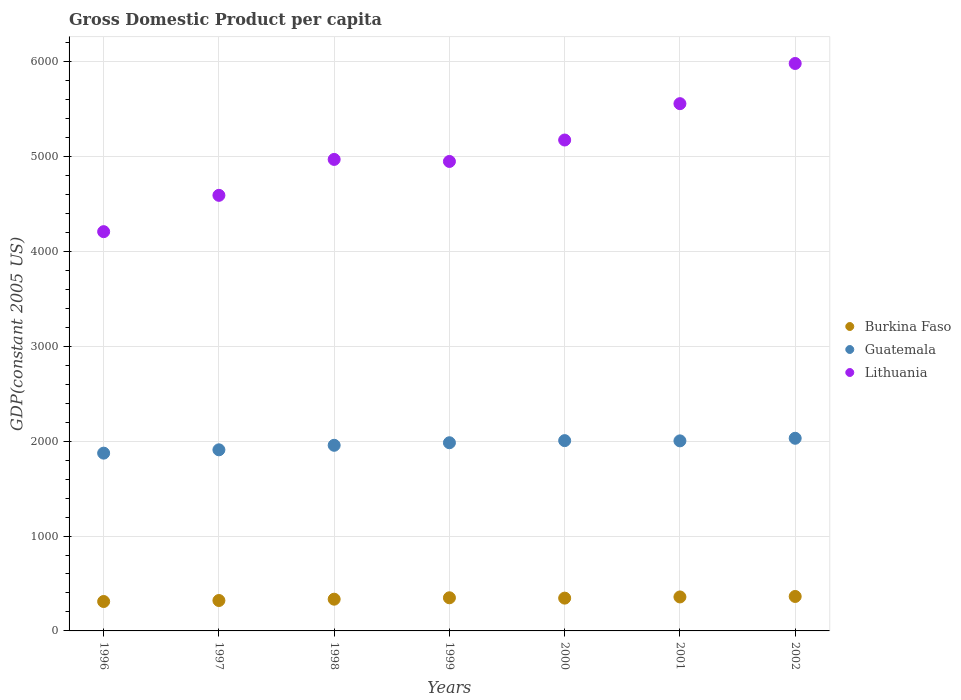How many different coloured dotlines are there?
Offer a very short reply. 3. Is the number of dotlines equal to the number of legend labels?
Offer a terse response. Yes. What is the GDP per capita in Lithuania in 1996?
Provide a succinct answer. 4207.88. Across all years, what is the maximum GDP per capita in Burkina Faso?
Keep it short and to the point. 363.15. Across all years, what is the minimum GDP per capita in Burkina Faso?
Make the answer very short. 310.01. In which year was the GDP per capita in Lithuania maximum?
Give a very brief answer. 2002. In which year was the GDP per capita in Lithuania minimum?
Provide a succinct answer. 1996. What is the total GDP per capita in Guatemala in the graph?
Offer a very short reply. 1.38e+04. What is the difference between the GDP per capita in Burkina Faso in 1997 and that in 2001?
Ensure brevity in your answer.  -37.58. What is the difference between the GDP per capita in Lithuania in 2002 and the GDP per capita in Burkina Faso in 1997?
Your answer should be compact. 5659.81. What is the average GDP per capita in Burkina Faso per year?
Offer a terse response. 340.16. In the year 2001, what is the difference between the GDP per capita in Guatemala and GDP per capita in Burkina Faso?
Offer a very short reply. 1644.84. What is the ratio of the GDP per capita in Guatemala in 1999 to that in 2001?
Offer a very short reply. 0.99. Is the difference between the GDP per capita in Guatemala in 1996 and 1998 greater than the difference between the GDP per capita in Burkina Faso in 1996 and 1998?
Give a very brief answer. No. What is the difference between the highest and the second highest GDP per capita in Burkina Faso?
Ensure brevity in your answer.  5.03. What is the difference between the highest and the lowest GDP per capita in Burkina Faso?
Provide a succinct answer. 53.14. Is the sum of the GDP per capita in Guatemala in 1996 and 2000 greater than the maximum GDP per capita in Lithuania across all years?
Provide a short and direct response. No. Is it the case that in every year, the sum of the GDP per capita in Burkina Faso and GDP per capita in Guatemala  is greater than the GDP per capita in Lithuania?
Your response must be concise. No. Does the GDP per capita in Burkina Faso monotonically increase over the years?
Ensure brevity in your answer.  No. What is the difference between two consecutive major ticks on the Y-axis?
Ensure brevity in your answer.  1000. Are the values on the major ticks of Y-axis written in scientific E-notation?
Your answer should be very brief. No. How are the legend labels stacked?
Make the answer very short. Vertical. What is the title of the graph?
Your response must be concise. Gross Domestic Product per capita. What is the label or title of the Y-axis?
Your response must be concise. GDP(constant 2005 US). What is the GDP(constant 2005 US) in Burkina Faso in 1996?
Make the answer very short. 310.01. What is the GDP(constant 2005 US) of Guatemala in 1996?
Your answer should be very brief. 1873.62. What is the GDP(constant 2005 US) of Lithuania in 1996?
Your answer should be very brief. 4207.88. What is the GDP(constant 2005 US) in Burkina Faso in 1997?
Make the answer very short. 320.54. What is the GDP(constant 2005 US) in Guatemala in 1997?
Keep it short and to the point. 1908.72. What is the GDP(constant 2005 US) in Lithuania in 1997?
Offer a terse response. 4590.59. What is the GDP(constant 2005 US) of Burkina Faso in 1998?
Make the answer very short. 334.45. What is the GDP(constant 2005 US) in Guatemala in 1998?
Offer a terse response. 1956.34. What is the GDP(constant 2005 US) of Lithuania in 1998?
Make the answer very short. 4969.25. What is the GDP(constant 2005 US) in Burkina Faso in 1999?
Provide a short and direct response. 349.22. What is the GDP(constant 2005 US) in Guatemala in 1999?
Offer a very short reply. 1983.16. What is the GDP(constant 2005 US) in Lithuania in 1999?
Your response must be concise. 4947.85. What is the GDP(constant 2005 US) of Burkina Faso in 2000?
Provide a succinct answer. 345.62. What is the GDP(constant 2005 US) in Guatemala in 2000?
Keep it short and to the point. 2005.54. What is the GDP(constant 2005 US) in Lithuania in 2000?
Your answer should be very brief. 5173.69. What is the GDP(constant 2005 US) of Burkina Faso in 2001?
Give a very brief answer. 358.12. What is the GDP(constant 2005 US) in Guatemala in 2001?
Keep it short and to the point. 2002.96. What is the GDP(constant 2005 US) of Lithuania in 2001?
Provide a short and direct response. 5556.85. What is the GDP(constant 2005 US) of Burkina Faso in 2002?
Keep it short and to the point. 363.15. What is the GDP(constant 2005 US) in Guatemala in 2002?
Your response must be concise. 2030.31. What is the GDP(constant 2005 US) in Lithuania in 2002?
Provide a succinct answer. 5980.35. Across all years, what is the maximum GDP(constant 2005 US) in Burkina Faso?
Your answer should be very brief. 363.15. Across all years, what is the maximum GDP(constant 2005 US) of Guatemala?
Offer a terse response. 2030.31. Across all years, what is the maximum GDP(constant 2005 US) in Lithuania?
Provide a short and direct response. 5980.35. Across all years, what is the minimum GDP(constant 2005 US) in Burkina Faso?
Provide a short and direct response. 310.01. Across all years, what is the minimum GDP(constant 2005 US) of Guatemala?
Your answer should be very brief. 1873.62. Across all years, what is the minimum GDP(constant 2005 US) in Lithuania?
Keep it short and to the point. 4207.88. What is the total GDP(constant 2005 US) of Burkina Faso in the graph?
Ensure brevity in your answer.  2381.12. What is the total GDP(constant 2005 US) in Guatemala in the graph?
Keep it short and to the point. 1.38e+04. What is the total GDP(constant 2005 US) of Lithuania in the graph?
Give a very brief answer. 3.54e+04. What is the difference between the GDP(constant 2005 US) in Burkina Faso in 1996 and that in 1997?
Keep it short and to the point. -10.53. What is the difference between the GDP(constant 2005 US) of Guatemala in 1996 and that in 1997?
Keep it short and to the point. -35.1. What is the difference between the GDP(constant 2005 US) in Lithuania in 1996 and that in 1997?
Keep it short and to the point. -382.71. What is the difference between the GDP(constant 2005 US) of Burkina Faso in 1996 and that in 1998?
Give a very brief answer. -24.44. What is the difference between the GDP(constant 2005 US) of Guatemala in 1996 and that in 1998?
Ensure brevity in your answer.  -82.72. What is the difference between the GDP(constant 2005 US) of Lithuania in 1996 and that in 1998?
Your response must be concise. -761.37. What is the difference between the GDP(constant 2005 US) of Burkina Faso in 1996 and that in 1999?
Your answer should be compact. -39.21. What is the difference between the GDP(constant 2005 US) in Guatemala in 1996 and that in 1999?
Give a very brief answer. -109.54. What is the difference between the GDP(constant 2005 US) of Lithuania in 1996 and that in 1999?
Ensure brevity in your answer.  -739.97. What is the difference between the GDP(constant 2005 US) of Burkina Faso in 1996 and that in 2000?
Your answer should be very brief. -35.61. What is the difference between the GDP(constant 2005 US) in Guatemala in 1996 and that in 2000?
Give a very brief answer. -131.92. What is the difference between the GDP(constant 2005 US) of Lithuania in 1996 and that in 2000?
Provide a succinct answer. -965.82. What is the difference between the GDP(constant 2005 US) in Burkina Faso in 1996 and that in 2001?
Offer a very short reply. -48.11. What is the difference between the GDP(constant 2005 US) of Guatemala in 1996 and that in 2001?
Your answer should be very brief. -129.34. What is the difference between the GDP(constant 2005 US) in Lithuania in 1996 and that in 2001?
Offer a very short reply. -1348.97. What is the difference between the GDP(constant 2005 US) in Burkina Faso in 1996 and that in 2002?
Give a very brief answer. -53.14. What is the difference between the GDP(constant 2005 US) of Guatemala in 1996 and that in 2002?
Provide a succinct answer. -156.69. What is the difference between the GDP(constant 2005 US) of Lithuania in 1996 and that in 2002?
Your answer should be very brief. -1772.47. What is the difference between the GDP(constant 2005 US) in Burkina Faso in 1997 and that in 1998?
Keep it short and to the point. -13.91. What is the difference between the GDP(constant 2005 US) in Guatemala in 1997 and that in 1998?
Ensure brevity in your answer.  -47.62. What is the difference between the GDP(constant 2005 US) of Lithuania in 1997 and that in 1998?
Provide a succinct answer. -378.66. What is the difference between the GDP(constant 2005 US) in Burkina Faso in 1997 and that in 1999?
Provide a short and direct response. -28.68. What is the difference between the GDP(constant 2005 US) of Guatemala in 1997 and that in 1999?
Ensure brevity in your answer.  -74.45. What is the difference between the GDP(constant 2005 US) in Lithuania in 1997 and that in 1999?
Make the answer very short. -357.25. What is the difference between the GDP(constant 2005 US) in Burkina Faso in 1997 and that in 2000?
Offer a very short reply. -25.09. What is the difference between the GDP(constant 2005 US) in Guatemala in 1997 and that in 2000?
Make the answer very short. -96.82. What is the difference between the GDP(constant 2005 US) in Lithuania in 1997 and that in 2000?
Provide a succinct answer. -583.1. What is the difference between the GDP(constant 2005 US) in Burkina Faso in 1997 and that in 2001?
Your answer should be compact. -37.58. What is the difference between the GDP(constant 2005 US) in Guatemala in 1997 and that in 2001?
Offer a very short reply. -94.24. What is the difference between the GDP(constant 2005 US) of Lithuania in 1997 and that in 2001?
Your answer should be compact. -966.26. What is the difference between the GDP(constant 2005 US) of Burkina Faso in 1997 and that in 2002?
Your answer should be very brief. -42.61. What is the difference between the GDP(constant 2005 US) in Guatemala in 1997 and that in 2002?
Keep it short and to the point. -121.6. What is the difference between the GDP(constant 2005 US) in Lithuania in 1997 and that in 2002?
Give a very brief answer. -1389.76. What is the difference between the GDP(constant 2005 US) of Burkina Faso in 1998 and that in 1999?
Give a very brief answer. -14.77. What is the difference between the GDP(constant 2005 US) in Guatemala in 1998 and that in 1999?
Provide a short and direct response. -26.83. What is the difference between the GDP(constant 2005 US) of Lithuania in 1998 and that in 1999?
Provide a succinct answer. 21.4. What is the difference between the GDP(constant 2005 US) of Burkina Faso in 1998 and that in 2000?
Provide a short and direct response. -11.17. What is the difference between the GDP(constant 2005 US) of Guatemala in 1998 and that in 2000?
Offer a terse response. -49.2. What is the difference between the GDP(constant 2005 US) of Lithuania in 1998 and that in 2000?
Your answer should be compact. -204.45. What is the difference between the GDP(constant 2005 US) in Burkina Faso in 1998 and that in 2001?
Offer a very short reply. -23.67. What is the difference between the GDP(constant 2005 US) of Guatemala in 1998 and that in 2001?
Your answer should be very brief. -46.62. What is the difference between the GDP(constant 2005 US) in Lithuania in 1998 and that in 2001?
Your response must be concise. -587.6. What is the difference between the GDP(constant 2005 US) in Burkina Faso in 1998 and that in 2002?
Offer a very short reply. -28.7. What is the difference between the GDP(constant 2005 US) of Guatemala in 1998 and that in 2002?
Provide a succinct answer. -73.98. What is the difference between the GDP(constant 2005 US) in Lithuania in 1998 and that in 2002?
Keep it short and to the point. -1011.1. What is the difference between the GDP(constant 2005 US) in Burkina Faso in 1999 and that in 2000?
Give a very brief answer. 3.6. What is the difference between the GDP(constant 2005 US) of Guatemala in 1999 and that in 2000?
Provide a short and direct response. -22.38. What is the difference between the GDP(constant 2005 US) in Lithuania in 1999 and that in 2000?
Ensure brevity in your answer.  -225.85. What is the difference between the GDP(constant 2005 US) in Burkina Faso in 1999 and that in 2001?
Provide a short and direct response. -8.9. What is the difference between the GDP(constant 2005 US) of Guatemala in 1999 and that in 2001?
Make the answer very short. -19.79. What is the difference between the GDP(constant 2005 US) of Lithuania in 1999 and that in 2001?
Make the answer very short. -609. What is the difference between the GDP(constant 2005 US) of Burkina Faso in 1999 and that in 2002?
Provide a short and direct response. -13.93. What is the difference between the GDP(constant 2005 US) in Guatemala in 1999 and that in 2002?
Provide a short and direct response. -47.15. What is the difference between the GDP(constant 2005 US) of Lithuania in 1999 and that in 2002?
Offer a terse response. -1032.5. What is the difference between the GDP(constant 2005 US) in Burkina Faso in 2000 and that in 2001?
Make the answer very short. -12.5. What is the difference between the GDP(constant 2005 US) in Guatemala in 2000 and that in 2001?
Offer a very short reply. 2.58. What is the difference between the GDP(constant 2005 US) in Lithuania in 2000 and that in 2001?
Your answer should be compact. -383.15. What is the difference between the GDP(constant 2005 US) of Burkina Faso in 2000 and that in 2002?
Offer a very short reply. -17.53. What is the difference between the GDP(constant 2005 US) of Guatemala in 2000 and that in 2002?
Ensure brevity in your answer.  -24.77. What is the difference between the GDP(constant 2005 US) in Lithuania in 2000 and that in 2002?
Offer a very short reply. -806.66. What is the difference between the GDP(constant 2005 US) in Burkina Faso in 2001 and that in 2002?
Ensure brevity in your answer.  -5.03. What is the difference between the GDP(constant 2005 US) of Guatemala in 2001 and that in 2002?
Give a very brief answer. -27.36. What is the difference between the GDP(constant 2005 US) in Lithuania in 2001 and that in 2002?
Your answer should be very brief. -423.5. What is the difference between the GDP(constant 2005 US) in Burkina Faso in 1996 and the GDP(constant 2005 US) in Guatemala in 1997?
Offer a very short reply. -1598.71. What is the difference between the GDP(constant 2005 US) of Burkina Faso in 1996 and the GDP(constant 2005 US) of Lithuania in 1997?
Make the answer very short. -4280.58. What is the difference between the GDP(constant 2005 US) in Guatemala in 1996 and the GDP(constant 2005 US) in Lithuania in 1997?
Provide a short and direct response. -2716.97. What is the difference between the GDP(constant 2005 US) of Burkina Faso in 1996 and the GDP(constant 2005 US) of Guatemala in 1998?
Keep it short and to the point. -1646.33. What is the difference between the GDP(constant 2005 US) of Burkina Faso in 1996 and the GDP(constant 2005 US) of Lithuania in 1998?
Provide a succinct answer. -4659.24. What is the difference between the GDP(constant 2005 US) of Guatemala in 1996 and the GDP(constant 2005 US) of Lithuania in 1998?
Offer a terse response. -3095.63. What is the difference between the GDP(constant 2005 US) of Burkina Faso in 1996 and the GDP(constant 2005 US) of Guatemala in 1999?
Your response must be concise. -1673.15. What is the difference between the GDP(constant 2005 US) in Burkina Faso in 1996 and the GDP(constant 2005 US) in Lithuania in 1999?
Your answer should be very brief. -4637.84. What is the difference between the GDP(constant 2005 US) in Guatemala in 1996 and the GDP(constant 2005 US) in Lithuania in 1999?
Give a very brief answer. -3074.23. What is the difference between the GDP(constant 2005 US) in Burkina Faso in 1996 and the GDP(constant 2005 US) in Guatemala in 2000?
Give a very brief answer. -1695.53. What is the difference between the GDP(constant 2005 US) of Burkina Faso in 1996 and the GDP(constant 2005 US) of Lithuania in 2000?
Give a very brief answer. -4863.69. What is the difference between the GDP(constant 2005 US) of Guatemala in 1996 and the GDP(constant 2005 US) of Lithuania in 2000?
Offer a very short reply. -3300.07. What is the difference between the GDP(constant 2005 US) in Burkina Faso in 1996 and the GDP(constant 2005 US) in Guatemala in 2001?
Your answer should be very brief. -1692.95. What is the difference between the GDP(constant 2005 US) in Burkina Faso in 1996 and the GDP(constant 2005 US) in Lithuania in 2001?
Make the answer very short. -5246.84. What is the difference between the GDP(constant 2005 US) of Guatemala in 1996 and the GDP(constant 2005 US) of Lithuania in 2001?
Your response must be concise. -3683.23. What is the difference between the GDP(constant 2005 US) of Burkina Faso in 1996 and the GDP(constant 2005 US) of Guatemala in 2002?
Offer a very short reply. -1720.3. What is the difference between the GDP(constant 2005 US) of Burkina Faso in 1996 and the GDP(constant 2005 US) of Lithuania in 2002?
Give a very brief answer. -5670.34. What is the difference between the GDP(constant 2005 US) of Guatemala in 1996 and the GDP(constant 2005 US) of Lithuania in 2002?
Make the answer very short. -4106.73. What is the difference between the GDP(constant 2005 US) in Burkina Faso in 1997 and the GDP(constant 2005 US) in Guatemala in 1998?
Your answer should be very brief. -1635.8. What is the difference between the GDP(constant 2005 US) of Burkina Faso in 1997 and the GDP(constant 2005 US) of Lithuania in 1998?
Your answer should be compact. -4648.71. What is the difference between the GDP(constant 2005 US) in Guatemala in 1997 and the GDP(constant 2005 US) in Lithuania in 1998?
Your answer should be very brief. -3060.53. What is the difference between the GDP(constant 2005 US) in Burkina Faso in 1997 and the GDP(constant 2005 US) in Guatemala in 1999?
Offer a terse response. -1662.62. What is the difference between the GDP(constant 2005 US) in Burkina Faso in 1997 and the GDP(constant 2005 US) in Lithuania in 1999?
Your response must be concise. -4627.31. What is the difference between the GDP(constant 2005 US) in Guatemala in 1997 and the GDP(constant 2005 US) in Lithuania in 1999?
Give a very brief answer. -3039.13. What is the difference between the GDP(constant 2005 US) in Burkina Faso in 1997 and the GDP(constant 2005 US) in Guatemala in 2000?
Ensure brevity in your answer.  -1685. What is the difference between the GDP(constant 2005 US) of Burkina Faso in 1997 and the GDP(constant 2005 US) of Lithuania in 2000?
Provide a short and direct response. -4853.16. What is the difference between the GDP(constant 2005 US) of Guatemala in 1997 and the GDP(constant 2005 US) of Lithuania in 2000?
Offer a terse response. -3264.98. What is the difference between the GDP(constant 2005 US) in Burkina Faso in 1997 and the GDP(constant 2005 US) in Guatemala in 2001?
Give a very brief answer. -1682.42. What is the difference between the GDP(constant 2005 US) in Burkina Faso in 1997 and the GDP(constant 2005 US) in Lithuania in 2001?
Provide a short and direct response. -5236.31. What is the difference between the GDP(constant 2005 US) in Guatemala in 1997 and the GDP(constant 2005 US) in Lithuania in 2001?
Keep it short and to the point. -3648.13. What is the difference between the GDP(constant 2005 US) in Burkina Faso in 1997 and the GDP(constant 2005 US) in Guatemala in 2002?
Provide a short and direct response. -1709.77. What is the difference between the GDP(constant 2005 US) of Burkina Faso in 1997 and the GDP(constant 2005 US) of Lithuania in 2002?
Your answer should be compact. -5659.81. What is the difference between the GDP(constant 2005 US) of Guatemala in 1997 and the GDP(constant 2005 US) of Lithuania in 2002?
Give a very brief answer. -4071.63. What is the difference between the GDP(constant 2005 US) in Burkina Faso in 1998 and the GDP(constant 2005 US) in Guatemala in 1999?
Offer a terse response. -1648.71. What is the difference between the GDP(constant 2005 US) in Burkina Faso in 1998 and the GDP(constant 2005 US) in Lithuania in 1999?
Make the answer very short. -4613.39. What is the difference between the GDP(constant 2005 US) of Guatemala in 1998 and the GDP(constant 2005 US) of Lithuania in 1999?
Provide a short and direct response. -2991.51. What is the difference between the GDP(constant 2005 US) in Burkina Faso in 1998 and the GDP(constant 2005 US) in Guatemala in 2000?
Provide a short and direct response. -1671.09. What is the difference between the GDP(constant 2005 US) of Burkina Faso in 1998 and the GDP(constant 2005 US) of Lithuania in 2000?
Give a very brief answer. -4839.24. What is the difference between the GDP(constant 2005 US) of Guatemala in 1998 and the GDP(constant 2005 US) of Lithuania in 2000?
Offer a terse response. -3217.36. What is the difference between the GDP(constant 2005 US) in Burkina Faso in 1998 and the GDP(constant 2005 US) in Guatemala in 2001?
Provide a short and direct response. -1668.51. What is the difference between the GDP(constant 2005 US) in Burkina Faso in 1998 and the GDP(constant 2005 US) in Lithuania in 2001?
Offer a terse response. -5222.4. What is the difference between the GDP(constant 2005 US) of Guatemala in 1998 and the GDP(constant 2005 US) of Lithuania in 2001?
Make the answer very short. -3600.51. What is the difference between the GDP(constant 2005 US) in Burkina Faso in 1998 and the GDP(constant 2005 US) in Guatemala in 2002?
Provide a succinct answer. -1695.86. What is the difference between the GDP(constant 2005 US) in Burkina Faso in 1998 and the GDP(constant 2005 US) in Lithuania in 2002?
Provide a short and direct response. -5645.9. What is the difference between the GDP(constant 2005 US) in Guatemala in 1998 and the GDP(constant 2005 US) in Lithuania in 2002?
Keep it short and to the point. -4024.01. What is the difference between the GDP(constant 2005 US) of Burkina Faso in 1999 and the GDP(constant 2005 US) of Guatemala in 2000?
Provide a short and direct response. -1656.32. What is the difference between the GDP(constant 2005 US) in Burkina Faso in 1999 and the GDP(constant 2005 US) in Lithuania in 2000?
Offer a very short reply. -4824.47. What is the difference between the GDP(constant 2005 US) of Guatemala in 1999 and the GDP(constant 2005 US) of Lithuania in 2000?
Keep it short and to the point. -3190.53. What is the difference between the GDP(constant 2005 US) in Burkina Faso in 1999 and the GDP(constant 2005 US) in Guatemala in 2001?
Your answer should be very brief. -1653.74. What is the difference between the GDP(constant 2005 US) of Burkina Faso in 1999 and the GDP(constant 2005 US) of Lithuania in 2001?
Your response must be concise. -5207.63. What is the difference between the GDP(constant 2005 US) of Guatemala in 1999 and the GDP(constant 2005 US) of Lithuania in 2001?
Your answer should be compact. -3573.69. What is the difference between the GDP(constant 2005 US) in Burkina Faso in 1999 and the GDP(constant 2005 US) in Guatemala in 2002?
Your answer should be very brief. -1681.09. What is the difference between the GDP(constant 2005 US) in Burkina Faso in 1999 and the GDP(constant 2005 US) in Lithuania in 2002?
Offer a terse response. -5631.13. What is the difference between the GDP(constant 2005 US) of Guatemala in 1999 and the GDP(constant 2005 US) of Lithuania in 2002?
Keep it short and to the point. -3997.19. What is the difference between the GDP(constant 2005 US) of Burkina Faso in 2000 and the GDP(constant 2005 US) of Guatemala in 2001?
Provide a succinct answer. -1657.33. What is the difference between the GDP(constant 2005 US) of Burkina Faso in 2000 and the GDP(constant 2005 US) of Lithuania in 2001?
Offer a very short reply. -5211.23. What is the difference between the GDP(constant 2005 US) in Guatemala in 2000 and the GDP(constant 2005 US) in Lithuania in 2001?
Keep it short and to the point. -3551.31. What is the difference between the GDP(constant 2005 US) of Burkina Faso in 2000 and the GDP(constant 2005 US) of Guatemala in 2002?
Your answer should be very brief. -1684.69. What is the difference between the GDP(constant 2005 US) in Burkina Faso in 2000 and the GDP(constant 2005 US) in Lithuania in 2002?
Your answer should be compact. -5634.73. What is the difference between the GDP(constant 2005 US) of Guatemala in 2000 and the GDP(constant 2005 US) of Lithuania in 2002?
Keep it short and to the point. -3974.81. What is the difference between the GDP(constant 2005 US) of Burkina Faso in 2001 and the GDP(constant 2005 US) of Guatemala in 2002?
Provide a succinct answer. -1672.19. What is the difference between the GDP(constant 2005 US) of Burkina Faso in 2001 and the GDP(constant 2005 US) of Lithuania in 2002?
Provide a short and direct response. -5622.23. What is the difference between the GDP(constant 2005 US) of Guatemala in 2001 and the GDP(constant 2005 US) of Lithuania in 2002?
Offer a terse response. -3977.39. What is the average GDP(constant 2005 US) of Burkina Faso per year?
Offer a very short reply. 340.16. What is the average GDP(constant 2005 US) in Guatemala per year?
Provide a succinct answer. 1965.81. What is the average GDP(constant 2005 US) of Lithuania per year?
Ensure brevity in your answer.  5060.92. In the year 1996, what is the difference between the GDP(constant 2005 US) of Burkina Faso and GDP(constant 2005 US) of Guatemala?
Provide a short and direct response. -1563.61. In the year 1996, what is the difference between the GDP(constant 2005 US) in Burkina Faso and GDP(constant 2005 US) in Lithuania?
Keep it short and to the point. -3897.87. In the year 1996, what is the difference between the GDP(constant 2005 US) in Guatemala and GDP(constant 2005 US) in Lithuania?
Make the answer very short. -2334.26. In the year 1997, what is the difference between the GDP(constant 2005 US) in Burkina Faso and GDP(constant 2005 US) in Guatemala?
Your response must be concise. -1588.18. In the year 1997, what is the difference between the GDP(constant 2005 US) in Burkina Faso and GDP(constant 2005 US) in Lithuania?
Your answer should be compact. -4270.05. In the year 1997, what is the difference between the GDP(constant 2005 US) in Guatemala and GDP(constant 2005 US) in Lithuania?
Your answer should be compact. -2681.88. In the year 1998, what is the difference between the GDP(constant 2005 US) in Burkina Faso and GDP(constant 2005 US) in Guatemala?
Your answer should be compact. -1621.89. In the year 1998, what is the difference between the GDP(constant 2005 US) of Burkina Faso and GDP(constant 2005 US) of Lithuania?
Your answer should be very brief. -4634.8. In the year 1998, what is the difference between the GDP(constant 2005 US) in Guatemala and GDP(constant 2005 US) in Lithuania?
Your answer should be compact. -3012.91. In the year 1999, what is the difference between the GDP(constant 2005 US) in Burkina Faso and GDP(constant 2005 US) in Guatemala?
Your response must be concise. -1633.94. In the year 1999, what is the difference between the GDP(constant 2005 US) in Burkina Faso and GDP(constant 2005 US) in Lithuania?
Provide a short and direct response. -4598.63. In the year 1999, what is the difference between the GDP(constant 2005 US) in Guatemala and GDP(constant 2005 US) in Lithuania?
Provide a short and direct response. -2964.68. In the year 2000, what is the difference between the GDP(constant 2005 US) of Burkina Faso and GDP(constant 2005 US) of Guatemala?
Keep it short and to the point. -1659.91. In the year 2000, what is the difference between the GDP(constant 2005 US) in Burkina Faso and GDP(constant 2005 US) in Lithuania?
Ensure brevity in your answer.  -4828.07. In the year 2000, what is the difference between the GDP(constant 2005 US) of Guatemala and GDP(constant 2005 US) of Lithuania?
Make the answer very short. -3168.16. In the year 2001, what is the difference between the GDP(constant 2005 US) of Burkina Faso and GDP(constant 2005 US) of Guatemala?
Your answer should be very brief. -1644.84. In the year 2001, what is the difference between the GDP(constant 2005 US) of Burkina Faso and GDP(constant 2005 US) of Lithuania?
Your answer should be very brief. -5198.73. In the year 2001, what is the difference between the GDP(constant 2005 US) in Guatemala and GDP(constant 2005 US) in Lithuania?
Your answer should be compact. -3553.89. In the year 2002, what is the difference between the GDP(constant 2005 US) in Burkina Faso and GDP(constant 2005 US) in Guatemala?
Offer a terse response. -1667.16. In the year 2002, what is the difference between the GDP(constant 2005 US) of Burkina Faso and GDP(constant 2005 US) of Lithuania?
Make the answer very short. -5617.2. In the year 2002, what is the difference between the GDP(constant 2005 US) in Guatemala and GDP(constant 2005 US) in Lithuania?
Give a very brief answer. -3950.04. What is the ratio of the GDP(constant 2005 US) in Burkina Faso in 1996 to that in 1997?
Ensure brevity in your answer.  0.97. What is the ratio of the GDP(constant 2005 US) in Guatemala in 1996 to that in 1997?
Ensure brevity in your answer.  0.98. What is the ratio of the GDP(constant 2005 US) of Lithuania in 1996 to that in 1997?
Provide a short and direct response. 0.92. What is the ratio of the GDP(constant 2005 US) in Burkina Faso in 1996 to that in 1998?
Offer a very short reply. 0.93. What is the ratio of the GDP(constant 2005 US) of Guatemala in 1996 to that in 1998?
Offer a terse response. 0.96. What is the ratio of the GDP(constant 2005 US) of Lithuania in 1996 to that in 1998?
Make the answer very short. 0.85. What is the ratio of the GDP(constant 2005 US) of Burkina Faso in 1996 to that in 1999?
Provide a short and direct response. 0.89. What is the ratio of the GDP(constant 2005 US) in Guatemala in 1996 to that in 1999?
Provide a succinct answer. 0.94. What is the ratio of the GDP(constant 2005 US) of Lithuania in 1996 to that in 1999?
Your response must be concise. 0.85. What is the ratio of the GDP(constant 2005 US) in Burkina Faso in 1996 to that in 2000?
Your answer should be compact. 0.9. What is the ratio of the GDP(constant 2005 US) in Guatemala in 1996 to that in 2000?
Ensure brevity in your answer.  0.93. What is the ratio of the GDP(constant 2005 US) in Lithuania in 1996 to that in 2000?
Keep it short and to the point. 0.81. What is the ratio of the GDP(constant 2005 US) of Burkina Faso in 1996 to that in 2001?
Your answer should be very brief. 0.87. What is the ratio of the GDP(constant 2005 US) in Guatemala in 1996 to that in 2001?
Provide a short and direct response. 0.94. What is the ratio of the GDP(constant 2005 US) in Lithuania in 1996 to that in 2001?
Give a very brief answer. 0.76. What is the ratio of the GDP(constant 2005 US) of Burkina Faso in 1996 to that in 2002?
Give a very brief answer. 0.85. What is the ratio of the GDP(constant 2005 US) in Guatemala in 1996 to that in 2002?
Ensure brevity in your answer.  0.92. What is the ratio of the GDP(constant 2005 US) in Lithuania in 1996 to that in 2002?
Make the answer very short. 0.7. What is the ratio of the GDP(constant 2005 US) of Burkina Faso in 1997 to that in 1998?
Provide a short and direct response. 0.96. What is the ratio of the GDP(constant 2005 US) of Guatemala in 1997 to that in 1998?
Keep it short and to the point. 0.98. What is the ratio of the GDP(constant 2005 US) in Lithuania in 1997 to that in 1998?
Keep it short and to the point. 0.92. What is the ratio of the GDP(constant 2005 US) in Burkina Faso in 1997 to that in 1999?
Provide a succinct answer. 0.92. What is the ratio of the GDP(constant 2005 US) of Guatemala in 1997 to that in 1999?
Give a very brief answer. 0.96. What is the ratio of the GDP(constant 2005 US) of Lithuania in 1997 to that in 1999?
Provide a succinct answer. 0.93. What is the ratio of the GDP(constant 2005 US) in Burkina Faso in 1997 to that in 2000?
Make the answer very short. 0.93. What is the ratio of the GDP(constant 2005 US) in Guatemala in 1997 to that in 2000?
Make the answer very short. 0.95. What is the ratio of the GDP(constant 2005 US) of Lithuania in 1997 to that in 2000?
Offer a terse response. 0.89. What is the ratio of the GDP(constant 2005 US) in Burkina Faso in 1997 to that in 2001?
Offer a very short reply. 0.9. What is the ratio of the GDP(constant 2005 US) in Guatemala in 1997 to that in 2001?
Provide a short and direct response. 0.95. What is the ratio of the GDP(constant 2005 US) in Lithuania in 1997 to that in 2001?
Offer a very short reply. 0.83. What is the ratio of the GDP(constant 2005 US) of Burkina Faso in 1997 to that in 2002?
Your response must be concise. 0.88. What is the ratio of the GDP(constant 2005 US) in Guatemala in 1997 to that in 2002?
Provide a succinct answer. 0.94. What is the ratio of the GDP(constant 2005 US) in Lithuania in 1997 to that in 2002?
Keep it short and to the point. 0.77. What is the ratio of the GDP(constant 2005 US) of Burkina Faso in 1998 to that in 1999?
Your response must be concise. 0.96. What is the ratio of the GDP(constant 2005 US) in Guatemala in 1998 to that in 1999?
Your answer should be compact. 0.99. What is the ratio of the GDP(constant 2005 US) of Lithuania in 1998 to that in 1999?
Keep it short and to the point. 1. What is the ratio of the GDP(constant 2005 US) in Guatemala in 1998 to that in 2000?
Your answer should be very brief. 0.98. What is the ratio of the GDP(constant 2005 US) of Lithuania in 1998 to that in 2000?
Provide a short and direct response. 0.96. What is the ratio of the GDP(constant 2005 US) of Burkina Faso in 1998 to that in 2001?
Offer a terse response. 0.93. What is the ratio of the GDP(constant 2005 US) in Guatemala in 1998 to that in 2001?
Offer a terse response. 0.98. What is the ratio of the GDP(constant 2005 US) of Lithuania in 1998 to that in 2001?
Make the answer very short. 0.89. What is the ratio of the GDP(constant 2005 US) in Burkina Faso in 1998 to that in 2002?
Make the answer very short. 0.92. What is the ratio of the GDP(constant 2005 US) of Guatemala in 1998 to that in 2002?
Make the answer very short. 0.96. What is the ratio of the GDP(constant 2005 US) in Lithuania in 1998 to that in 2002?
Provide a succinct answer. 0.83. What is the ratio of the GDP(constant 2005 US) of Burkina Faso in 1999 to that in 2000?
Your response must be concise. 1.01. What is the ratio of the GDP(constant 2005 US) of Guatemala in 1999 to that in 2000?
Provide a short and direct response. 0.99. What is the ratio of the GDP(constant 2005 US) in Lithuania in 1999 to that in 2000?
Ensure brevity in your answer.  0.96. What is the ratio of the GDP(constant 2005 US) of Burkina Faso in 1999 to that in 2001?
Ensure brevity in your answer.  0.98. What is the ratio of the GDP(constant 2005 US) of Guatemala in 1999 to that in 2001?
Ensure brevity in your answer.  0.99. What is the ratio of the GDP(constant 2005 US) of Lithuania in 1999 to that in 2001?
Offer a terse response. 0.89. What is the ratio of the GDP(constant 2005 US) in Burkina Faso in 1999 to that in 2002?
Offer a very short reply. 0.96. What is the ratio of the GDP(constant 2005 US) of Guatemala in 1999 to that in 2002?
Your answer should be compact. 0.98. What is the ratio of the GDP(constant 2005 US) in Lithuania in 1999 to that in 2002?
Provide a short and direct response. 0.83. What is the ratio of the GDP(constant 2005 US) in Burkina Faso in 2000 to that in 2001?
Offer a very short reply. 0.97. What is the ratio of the GDP(constant 2005 US) in Guatemala in 2000 to that in 2001?
Your response must be concise. 1. What is the ratio of the GDP(constant 2005 US) in Lithuania in 2000 to that in 2001?
Provide a short and direct response. 0.93. What is the ratio of the GDP(constant 2005 US) of Burkina Faso in 2000 to that in 2002?
Keep it short and to the point. 0.95. What is the ratio of the GDP(constant 2005 US) of Lithuania in 2000 to that in 2002?
Make the answer very short. 0.87. What is the ratio of the GDP(constant 2005 US) of Burkina Faso in 2001 to that in 2002?
Give a very brief answer. 0.99. What is the ratio of the GDP(constant 2005 US) in Guatemala in 2001 to that in 2002?
Provide a short and direct response. 0.99. What is the ratio of the GDP(constant 2005 US) of Lithuania in 2001 to that in 2002?
Ensure brevity in your answer.  0.93. What is the difference between the highest and the second highest GDP(constant 2005 US) of Burkina Faso?
Offer a very short reply. 5.03. What is the difference between the highest and the second highest GDP(constant 2005 US) in Guatemala?
Your response must be concise. 24.77. What is the difference between the highest and the second highest GDP(constant 2005 US) in Lithuania?
Offer a very short reply. 423.5. What is the difference between the highest and the lowest GDP(constant 2005 US) of Burkina Faso?
Your response must be concise. 53.14. What is the difference between the highest and the lowest GDP(constant 2005 US) in Guatemala?
Make the answer very short. 156.69. What is the difference between the highest and the lowest GDP(constant 2005 US) in Lithuania?
Offer a very short reply. 1772.47. 